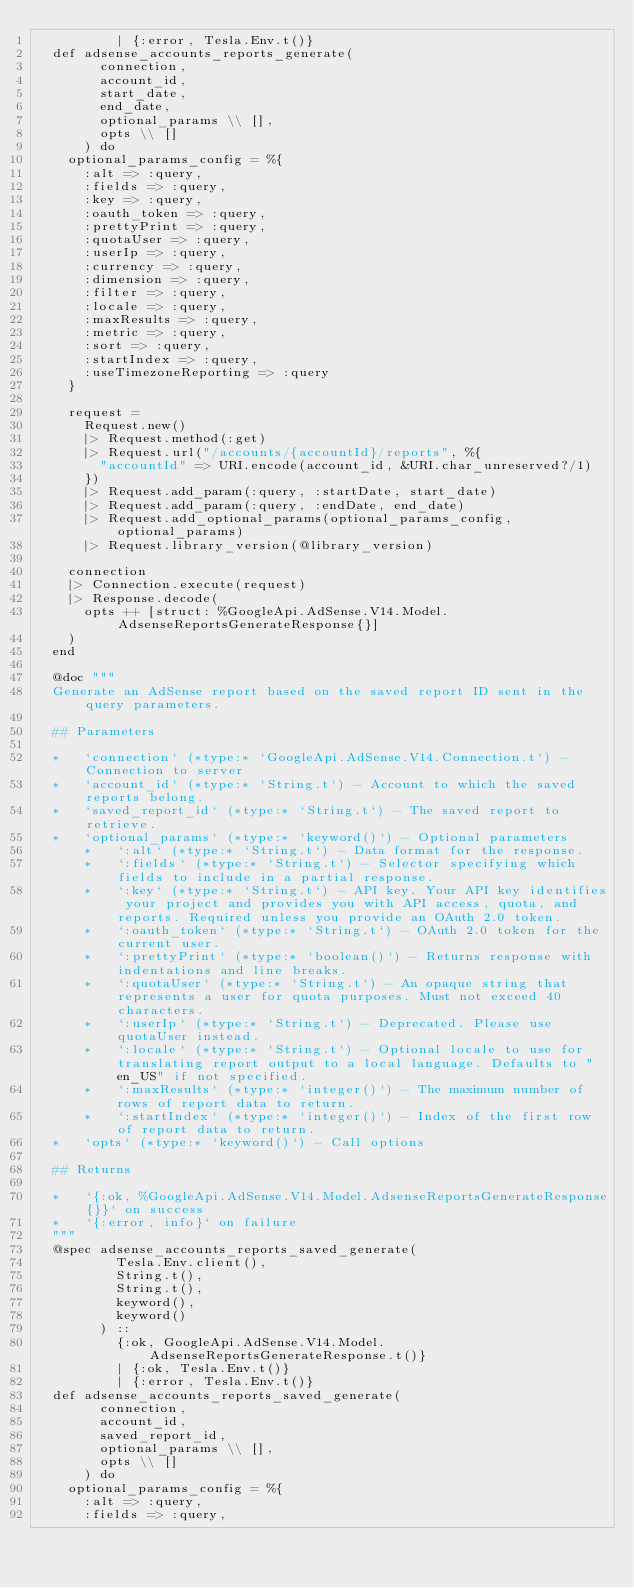Convert code to text. <code><loc_0><loc_0><loc_500><loc_500><_Elixir_>          | {:error, Tesla.Env.t()}
  def adsense_accounts_reports_generate(
        connection,
        account_id,
        start_date,
        end_date,
        optional_params \\ [],
        opts \\ []
      ) do
    optional_params_config = %{
      :alt => :query,
      :fields => :query,
      :key => :query,
      :oauth_token => :query,
      :prettyPrint => :query,
      :quotaUser => :query,
      :userIp => :query,
      :currency => :query,
      :dimension => :query,
      :filter => :query,
      :locale => :query,
      :maxResults => :query,
      :metric => :query,
      :sort => :query,
      :startIndex => :query,
      :useTimezoneReporting => :query
    }

    request =
      Request.new()
      |> Request.method(:get)
      |> Request.url("/accounts/{accountId}/reports", %{
        "accountId" => URI.encode(account_id, &URI.char_unreserved?/1)
      })
      |> Request.add_param(:query, :startDate, start_date)
      |> Request.add_param(:query, :endDate, end_date)
      |> Request.add_optional_params(optional_params_config, optional_params)
      |> Request.library_version(@library_version)

    connection
    |> Connection.execute(request)
    |> Response.decode(
      opts ++ [struct: %GoogleApi.AdSense.V14.Model.AdsenseReportsGenerateResponse{}]
    )
  end

  @doc """
  Generate an AdSense report based on the saved report ID sent in the query parameters.

  ## Parameters

  *   `connection` (*type:* `GoogleApi.AdSense.V14.Connection.t`) - Connection to server
  *   `account_id` (*type:* `String.t`) - Account to which the saved reports belong.
  *   `saved_report_id` (*type:* `String.t`) - The saved report to retrieve.
  *   `optional_params` (*type:* `keyword()`) - Optional parameters
      *   `:alt` (*type:* `String.t`) - Data format for the response.
      *   `:fields` (*type:* `String.t`) - Selector specifying which fields to include in a partial response.
      *   `:key` (*type:* `String.t`) - API key. Your API key identifies your project and provides you with API access, quota, and reports. Required unless you provide an OAuth 2.0 token.
      *   `:oauth_token` (*type:* `String.t`) - OAuth 2.0 token for the current user.
      *   `:prettyPrint` (*type:* `boolean()`) - Returns response with indentations and line breaks.
      *   `:quotaUser` (*type:* `String.t`) - An opaque string that represents a user for quota purposes. Must not exceed 40 characters.
      *   `:userIp` (*type:* `String.t`) - Deprecated. Please use quotaUser instead.
      *   `:locale` (*type:* `String.t`) - Optional locale to use for translating report output to a local language. Defaults to "en_US" if not specified.
      *   `:maxResults` (*type:* `integer()`) - The maximum number of rows of report data to return.
      *   `:startIndex` (*type:* `integer()`) - Index of the first row of report data to return.
  *   `opts` (*type:* `keyword()`) - Call options

  ## Returns

  *   `{:ok, %GoogleApi.AdSense.V14.Model.AdsenseReportsGenerateResponse{}}` on success
  *   `{:error, info}` on failure
  """
  @spec adsense_accounts_reports_saved_generate(
          Tesla.Env.client(),
          String.t(),
          String.t(),
          keyword(),
          keyword()
        ) ::
          {:ok, GoogleApi.AdSense.V14.Model.AdsenseReportsGenerateResponse.t()}
          | {:ok, Tesla.Env.t()}
          | {:error, Tesla.Env.t()}
  def adsense_accounts_reports_saved_generate(
        connection,
        account_id,
        saved_report_id,
        optional_params \\ [],
        opts \\ []
      ) do
    optional_params_config = %{
      :alt => :query,
      :fields => :query,</code> 